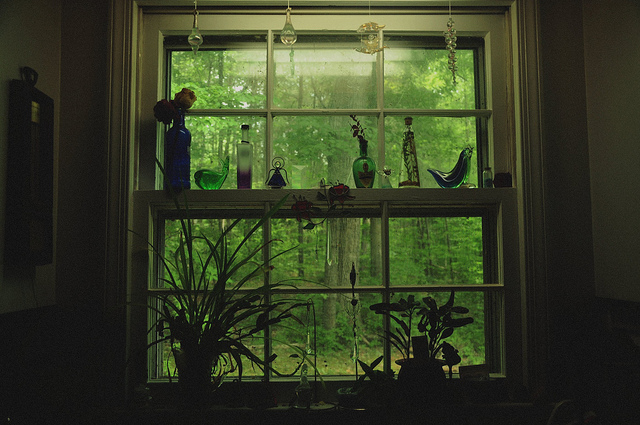Can you elaborate on the elements of the picture provided? The image showcases a beautifully decorated window with a collection of glass vases and potted plants. Starting from the left, near the top of the window, there is a tall blue vase with a plant. Just below it is a shorter, opaque vase. In the center, aligned near the top edge of the window frame, are three unique glass vases of varying shapes and colors, one of which is bird-shaped. On the far right side of the window, two more similar vases are positioned closely together, one slightly higher than the other. Additionally, in the bottom part of the window, vibrant green plants add a touch of nature, suggesting a well-cared-for indoor environment that complements the lush greenery visible outside the window. 